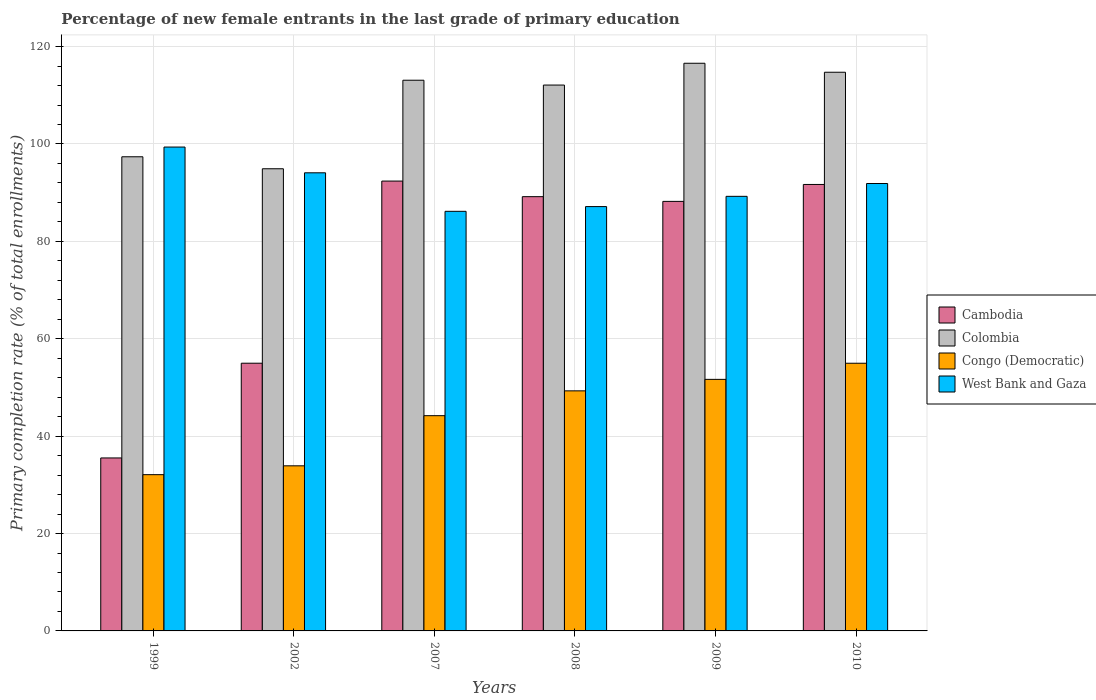How many different coloured bars are there?
Offer a terse response. 4. How many groups of bars are there?
Give a very brief answer. 6. Are the number of bars per tick equal to the number of legend labels?
Keep it short and to the point. Yes. Are the number of bars on each tick of the X-axis equal?
Offer a very short reply. Yes. How many bars are there on the 3rd tick from the right?
Ensure brevity in your answer.  4. What is the label of the 2nd group of bars from the left?
Offer a very short reply. 2002. What is the percentage of new female entrants in West Bank and Gaza in 2009?
Ensure brevity in your answer.  89.25. Across all years, what is the maximum percentage of new female entrants in Cambodia?
Give a very brief answer. 92.38. Across all years, what is the minimum percentage of new female entrants in Congo (Democratic)?
Your response must be concise. 32.09. In which year was the percentage of new female entrants in Congo (Democratic) minimum?
Your response must be concise. 1999. What is the total percentage of new female entrants in West Bank and Gaza in the graph?
Make the answer very short. 547.87. What is the difference between the percentage of new female entrants in Colombia in 1999 and that in 2010?
Offer a terse response. -17.36. What is the difference between the percentage of new female entrants in Cambodia in 2008 and the percentage of new female entrants in Colombia in 1999?
Your response must be concise. -8.19. What is the average percentage of new female entrants in West Bank and Gaza per year?
Ensure brevity in your answer.  91.31. In the year 2008, what is the difference between the percentage of new female entrants in Colombia and percentage of new female entrants in West Bank and Gaza?
Provide a short and direct response. 24.96. In how many years, is the percentage of new female entrants in West Bank and Gaza greater than 4 %?
Make the answer very short. 6. What is the ratio of the percentage of new female entrants in Cambodia in 1999 to that in 2010?
Offer a very short reply. 0.39. Is the percentage of new female entrants in Cambodia in 1999 less than that in 2010?
Give a very brief answer. Yes. Is the difference between the percentage of new female entrants in Colombia in 2002 and 2009 greater than the difference between the percentage of new female entrants in West Bank and Gaza in 2002 and 2009?
Your answer should be very brief. No. What is the difference between the highest and the second highest percentage of new female entrants in West Bank and Gaza?
Give a very brief answer. 5.29. What is the difference between the highest and the lowest percentage of new female entrants in Cambodia?
Your response must be concise. 56.86. In how many years, is the percentage of new female entrants in West Bank and Gaza greater than the average percentage of new female entrants in West Bank and Gaza taken over all years?
Give a very brief answer. 3. Is it the case that in every year, the sum of the percentage of new female entrants in West Bank and Gaza and percentage of new female entrants in Cambodia is greater than the sum of percentage of new female entrants in Colombia and percentage of new female entrants in Congo (Democratic)?
Give a very brief answer. No. What does the 4th bar from the left in 1999 represents?
Offer a terse response. West Bank and Gaza. What does the 4th bar from the right in 2002 represents?
Your response must be concise. Cambodia. Is it the case that in every year, the sum of the percentage of new female entrants in Cambodia and percentage of new female entrants in Congo (Democratic) is greater than the percentage of new female entrants in West Bank and Gaza?
Offer a very short reply. No. How many years are there in the graph?
Make the answer very short. 6. What is the difference between two consecutive major ticks on the Y-axis?
Ensure brevity in your answer.  20. Does the graph contain any zero values?
Your answer should be compact. No. Does the graph contain grids?
Provide a succinct answer. Yes. How many legend labels are there?
Offer a terse response. 4. How are the legend labels stacked?
Your answer should be compact. Vertical. What is the title of the graph?
Your answer should be compact. Percentage of new female entrants in the last grade of primary education. What is the label or title of the Y-axis?
Provide a short and direct response. Primary completion rate (% of total enrollments). What is the Primary completion rate (% of total enrollments) of Cambodia in 1999?
Your answer should be compact. 35.52. What is the Primary completion rate (% of total enrollments) in Colombia in 1999?
Your answer should be compact. 97.37. What is the Primary completion rate (% of total enrollments) in Congo (Democratic) in 1999?
Your answer should be compact. 32.09. What is the Primary completion rate (% of total enrollments) in West Bank and Gaza in 1999?
Offer a terse response. 99.36. What is the Primary completion rate (% of total enrollments) of Cambodia in 2002?
Offer a terse response. 54.98. What is the Primary completion rate (% of total enrollments) in Colombia in 2002?
Your response must be concise. 94.91. What is the Primary completion rate (% of total enrollments) in Congo (Democratic) in 2002?
Your response must be concise. 33.91. What is the Primary completion rate (% of total enrollments) of West Bank and Gaza in 2002?
Ensure brevity in your answer.  94.08. What is the Primary completion rate (% of total enrollments) of Cambodia in 2007?
Offer a terse response. 92.38. What is the Primary completion rate (% of total enrollments) in Colombia in 2007?
Make the answer very short. 113.09. What is the Primary completion rate (% of total enrollments) of Congo (Democratic) in 2007?
Keep it short and to the point. 44.2. What is the Primary completion rate (% of total enrollments) of West Bank and Gaza in 2007?
Offer a terse response. 86.17. What is the Primary completion rate (% of total enrollments) in Cambodia in 2008?
Offer a terse response. 89.18. What is the Primary completion rate (% of total enrollments) of Colombia in 2008?
Your answer should be compact. 112.1. What is the Primary completion rate (% of total enrollments) in Congo (Democratic) in 2008?
Make the answer very short. 49.3. What is the Primary completion rate (% of total enrollments) of West Bank and Gaza in 2008?
Keep it short and to the point. 87.14. What is the Primary completion rate (% of total enrollments) of Cambodia in 2009?
Provide a succinct answer. 88.21. What is the Primary completion rate (% of total enrollments) of Colombia in 2009?
Offer a terse response. 116.57. What is the Primary completion rate (% of total enrollments) of Congo (Democratic) in 2009?
Offer a terse response. 51.66. What is the Primary completion rate (% of total enrollments) in West Bank and Gaza in 2009?
Make the answer very short. 89.25. What is the Primary completion rate (% of total enrollments) of Cambodia in 2010?
Give a very brief answer. 91.68. What is the Primary completion rate (% of total enrollments) of Colombia in 2010?
Offer a terse response. 114.73. What is the Primary completion rate (% of total enrollments) in Congo (Democratic) in 2010?
Offer a very short reply. 54.97. What is the Primary completion rate (% of total enrollments) in West Bank and Gaza in 2010?
Offer a terse response. 91.88. Across all years, what is the maximum Primary completion rate (% of total enrollments) in Cambodia?
Provide a short and direct response. 92.38. Across all years, what is the maximum Primary completion rate (% of total enrollments) of Colombia?
Offer a terse response. 116.57. Across all years, what is the maximum Primary completion rate (% of total enrollments) of Congo (Democratic)?
Your response must be concise. 54.97. Across all years, what is the maximum Primary completion rate (% of total enrollments) in West Bank and Gaza?
Make the answer very short. 99.36. Across all years, what is the minimum Primary completion rate (% of total enrollments) in Cambodia?
Offer a terse response. 35.52. Across all years, what is the minimum Primary completion rate (% of total enrollments) in Colombia?
Give a very brief answer. 94.91. Across all years, what is the minimum Primary completion rate (% of total enrollments) of Congo (Democratic)?
Your answer should be compact. 32.09. Across all years, what is the minimum Primary completion rate (% of total enrollments) in West Bank and Gaza?
Provide a succinct answer. 86.17. What is the total Primary completion rate (% of total enrollments) in Cambodia in the graph?
Keep it short and to the point. 451.94. What is the total Primary completion rate (% of total enrollments) in Colombia in the graph?
Ensure brevity in your answer.  648.76. What is the total Primary completion rate (% of total enrollments) of Congo (Democratic) in the graph?
Make the answer very short. 266.12. What is the total Primary completion rate (% of total enrollments) in West Bank and Gaza in the graph?
Give a very brief answer. 547.87. What is the difference between the Primary completion rate (% of total enrollments) in Cambodia in 1999 and that in 2002?
Provide a succinct answer. -19.45. What is the difference between the Primary completion rate (% of total enrollments) of Colombia in 1999 and that in 2002?
Offer a very short reply. 2.46. What is the difference between the Primary completion rate (% of total enrollments) of Congo (Democratic) in 1999 and that in 2002?
Provide a succinct answer. -1.82. What is the difference between the Primary completion rate (% of total enrollments) of West Bank and Gaza in 1999 and that in 2002?
Ensure brevity in your answer.  5.29. What is the difference between the Primary completion rate (% of total enrollments) in Cambodia in 1999 and that in 2007?
Your answer should be compact. -56.86. What is the difference between the Primary completion rate (% of total enrollments) of Colombia in 1999 and that in 2007?
Your answer should be very brief. -15.72. What is the difference between the Primary completion rate (% of total enrollments) in Congo (Democratic) in 1999 and that in 2007?
Provide a short and direct response. -12.11. What is the difference between the Primary completion rate (% of total enrollments) of West Bank and Gaza in 1999 and that in 2007?
Keep it short and to the point. 13.2. What is the difference between the Primary completion rate (% of total enrollments) in Cambodia in 1999 and that in 2008?
Offer a very short reply. -53.66. What is the difference between the Primary completion rate (% of total enrollments) in Colombia in 1999 and that in 2008?
Provide a short and direct response. -14.73. What is the difference between the Primary completion rate (% of total enrollments) in Congo (Democratic) in 1999 and that in 2008?
Ensure brevity in your answer.  -17.21. What is the difference between the Primary completion rate (% of total enrollments) of West Bank and Gaza in 1999 and that in 2008?
Keep it short and to the point. 12.23. What is the difference between the Primary completion rate (% of total enrollments) in Cambodia in 1999 and that in 2009?
Provide a short and direct response. -52.69. What is the difference between the Primary completion rate (% of total enrollments) of Colombia in 1999 and that in 2009?
Provide a short and direct response. -19.2. What is the difference between the Primary completion rate (% of total enrollments) of Congo (Democratic) in 1999 and that in 2009?
Offer a very short reply. -19.57. What is the difference between the Primary completion rate (% of total enrollments) in West Bank and Gaza in 1999 and that in 2009?
Offer a very short reply. 10.12. What is the difference between the Primary completion rate (% of total enrollments) in Cambodia in 1999 and that in 2010?
Keep it short and to the point. -56.16. What is the difference between the Primary completion rate (% of total enrollments) of Colombia in 1999 and that in 2010?
Offer a very short reply. -17.36. What is the difference between the Primary completion rate (% of total enrollments) of Congo (Democratic) in 1999 and that in 2010?
Ensure brevity in your answer.  -22.88. What is the difference between the Primary completion rate (% of total enrollments) in West Bank and Gaza in 1999 and that in 2010?
Offer a very short reply. 7.49. What is the difference between the Primary completion rate (% of total enrollments) of Cambodia in 2002 and that in 2007?
Keep it short and to the point. -37.41. What is the difference between the Primary completion rate (% of total enrollments) of Colombia in 2002 and that in 2007?
Give a very brief answer. -18.18. What is the difference between the Primary completion rate (% of total enrollments) of Congo (Democratic) in 2002 and that in 2007?
Your answer should be very brief. -10.3. What is the difference between the Primary completion rate (% of total enrollments) in West Bank and Gaza in 2002 and that in 2007?
Ensure brevity in your answer.  7.91. What is the difference between the Primary completion rate (% of total enrollments) in Cambodia in 2002 and that in 2008?
Provide a succinct answer. -34.2. What is the difference between the Primary completion rate (% of total enrollments) of Colombia in 2002 and that in 2008?
Ensure brevity in your answer.  -17.19. What is the difference between the Primary completion rate (% of total enrollments) in Congo (Democratic) in 2002 and that in 2008?
Provide a short and direct response. -15.39. What is the difference between the Primary completion rate (% of total enrollments) in West Bank and Gaza in 2002 and that in 2008?
Provide a succinct answer. 6.94. What is the difference between the Primary completion rate (% of total enrollments) in Cambodia in 2002 and that in 2009?
Ensure brevity in your answer.  -33.23. What is the difference between the Primary completion rate (% of total enrollments) in Colombia in 2002 and that in 2009?
Ensure brevity in your answer.  -21.66. What is the difference between the Primary completion rate (% of total enrollments) of Congo (Democratic) in 2002 and that in 2009?
Ensure brevity in your answer.  -17.75. What is the difference between the Primary completion rate (% of total enrollments) of West Bank and Gaza in 2002 and that in 2009?
Your answer should be compact. 4.83. What is the difference between the Primary completion rate (% of total enrollments) of Cambodia in 2002 and that in 2010?
Your answer should be very brief. -36.71. What is the difference between the Primary completion rate (% of total enrollments) of Colombia in 2002 and that in 2010?
Provide a short and direct response. -19.82. What is the difference between the Primary completion rate (% of total enrollments) of Congo (Democratic) in 2002 and that in 2010?
Make the answer very short. -21.06. What is the difference between the Primary completion rate (% of total enrollments) of West Bank and Gaza in 2002 and that in 2010?
Keep it short and to the point. 2.2. What is the difference between the Primary completion rate (% of total enrollments) of Cambodia in 2007 and that in 2008?
Provide a short and direct response. 3.2. What is the difference between the Primary completion rate (% of total enrollments) in Colombia in 2007 and that in 2008?
Offer a very short reply. 0.99. What is the difference between the Primary completion rate (% of total enrollments) in Congo (Democratic) in 2007 and that in 2008?
Keep it short and to the point. -5.1. What is the difference between the Primary completion rate (% of total enrollments) of West Bank and Gaza in 2007 and that in 2008?
Your response must be concise. -0.97. What is the difference between the Primary completion rate (% of total enrollments) in Cambodia in 2007 and that in 2009?
Your answer should be very brief. 4.17. What is the difference between the Primary completion rate (% of total enrollments) in Colombia in 2007 and that in 2009?
Make the answer very short. -3.48. What is the difference between the Primary completion rate (% of total enrollments) of Congo (Democratic) in 2007 and that in 2009?
Your answer should be compact. -7.46. What is the difference between the Primary completion rate (% of total enrollments) in West Bank and Gaza in 2007 and that in 2009?
Your answer should be very brief. -3.08. What is the difference between the Primary completion rate (% of total enrollments) in Cambodia in 2007 and that in 2010?
Your answer should be very brief. 0.7. What is the difference between the Primary completion rate (% of total enrollments) of Colombia in 2007 and that in 2010?
Your answer should be compact. -1.64. What is the difference between the Primary completion rate (% of total enrollments) of Congo (Democratic) in 2007 and that in 2010?
Provide a succinct answer. -10.77. What is the difference between the Primary completion rate (% of total enrollments) of West Bank and Gaza in 2007 and that in 2010?
Your answer should be compact. -5.71. What is the difference between the Primary completion rate (% of total enrollments) in Cambodia in 2008 and that in 2009?
Make the answer very short. 0.97. What is the difference between the Primary completion rate (% of total enrollments) in Colombia in 2008 and that in 2009?
Keep it short and to the point. -4.47. What is the difference between the Primary completion rate (% of total enrollments) of Congo (Democratic) in 2008 and that in 2009?
Keep it short and to the point. -2.36. What is the difference between the Primary completion rate (% of total enrollments) of West Bank and Gaza in 2008 and that in 2009?
Ensure brevity in your answer.  -2.11. What is the difference between the Primary completion rate (% of total enrollments) in Cambodia in 2008 and that in 2010?
Provide a short and direct response. -2.5. What is the difference between the Primary completion rate (% of total enrollments) of Colombia in 2008 and that in 2010?
Keep it short and to the point. -2.63. What is the difference between the Primary completion rate (% of total enrollments) in Congo (Democratic) in 2008 and that in 2010?
Offer a very short reply. -5.67. What is the difference between the Primary completion rate (% of total enrollments) in West Bank and Gaza in 2008 and that in 2010?
Provide a short and direct response. -4.74. What is the difference between the Primary completion rate (% of total enrollments) of Cambodia in 2009 and that in 2010?
Your answer should be very brief. -3.47. What is the difference between the Primary completion rate (% of total enrollments) of Colombia in 2009 and that in 2010?
Your answer should be very brief. 1.85. What is the difference between the Primary completion rate (% of total enrollments) in Congo (Democratic) in 2009 and that in 2010?
Provide a succinct answer. -3.31. What is the difference between the Primary completion rate (% of total enrollments) of West Bank and Gaza in 2009 and that in 2010?
Offer a terse response. -2.63. What is the difference between the Primary completion rate (% of total enrollments) of Cambodia in 1999 and the Primary completion rate (% of total enrollments) of Colombia in 2002?
Offer a very short reply. -59.39. What is the difference between the Primary completion rate (% of total enrollments) in Cambodia in 1999 and the Primary completion rate (% of total enrollments) in Congo (Democratic) in 2002?
Give a very brief answer. 1.62. What is the difference between the Primary completion rate (% of total enrollments) of Cambodia in 1999 and the Primary completion rate (% of total enrollments) of West Bank and Gaza in 2002?
Make the answer very short. -58.56. What is the difference between the Primary completion rate (% of total enrollments) in Colombia in 1999 and the Primary completion rate (% of total enrollments) in Congo (Democratic) in 2002?
Your response must be concise. 63.46. What is the difference between the Primary completion rate (% of total enrollments) in Colombia in 1999 and the Primary completion rate (% of total enrollments) in West Bank and Gaza in 2002?
Provide a succinct answer. 3.29. What is the difference between the Primary completion rate (% of total enrollments) in Congo (Democratic) in 1999 and the Primary completion rate (% of total enrollments) in West Bank and Gaza in 2002?
Your answer should be compact. -61.99. What is the difference between the Primary completion rate (% of total enrollments) in Cambodia in 1999 and the Primary completion rate (% of total enrollments) in Colombia in 2007?
Your answer should be very brief. -77.57. What is the difference between the Primary completion rate (% of total enrollments) of Cambodia in 1999 and the Primary completion rate (% of total enrollments) of Congo (Democratic) in 2007?
Your answer should be compact. -8.68. What is the difference between the Primary completion rate (% of total enrollments) of Cambodia in 1999 and the Primary completion rate (% of total enrollments) of West Bank and Gaza in 2007?
Offer a very short reply. -50.65. What is the difference between the Primary completion rate (% of total enrollments) of Colombia in 1999 and the Primary completion rate (% of total enrollments) of Congo (Democratic) in 2007?
Offer a terse response. 53.17. What is the difference between the Primary completion rate (% of total enrollments) of Colombia in 1999 and the Primary completion rate (% of total enrollments) of West Bank and Gaza in 2007?
Give a very brief answer. 11.2. What is the difference between the Primary completion rate (% of total enrollments) of Congo (Democratic) in 1999 and the Primary completion rate (% of total enrollments) of West Bank and Gaza in 2007?
Give a very brief answer. -54.08. What is the difference between the Primary completion rate (% of total enrollments) in Cambodia in 1999 and the Primary completion rate (% of total enrollments) in Colombia in 2008?
Offer a very short reply. -76.58. What is the difference between the Primary completion rate (% of total enrollments) in Cambodia in 1999 and the Primary completion rate (% of total enrollments) in Congo (Democratic) in 2008?
Provide a succinct answer. -13.78. What is the difference between the Primary completion rate (% of total enrollments) in Cambodia in 1999 and the Primary completion rate (% of total enrollments) in West Bank and Gaza in 2008?
Offer a very short reply. -51.62. What is the difference between the Primary completion rate (% of total enrollments) in Colombia in 1999 and the Primary completion rate (% of total enrollments) in Congo (Democratic) in 2008?
Offer a terse response. 48.07. What is the difference between the Primary completion rate (% of total enrollments) of Colombia in 1999 and the Primary completion rate (% of total enrollments) of West Bank and Gaza in 2008?
Give a very brief answer. 10.23. What is the difference between the Primary completion rate (% of total enrollments) of Congo (Democratic) in 1999 and the Primary completion rate (% of total enrollments) of West Bank and Gaza in 2008?
Provide a short and direct response. -55.05. What is the difference between the Primary completion rate (% of total enrollments) in Cambodia in 1999 and the Primary completion rate (% of total enrollments) in Colombia in 2009?
Offer a very short reply. -81.05. What is the difference between the Primary completion rate (% of total enrollments) in Cambodia in 1999 and the Primary completion rate (% of total enrollments) in Congo (Democratic) in 2009?
Provide a succinct answer. -16.14. What is the difference between the Primary completion rate (% of total enrollments) in Cambodia in 1999 and the Primary completion rate (% of total enrollments) in West Bank and Gaza in 2009?
Give a very brief answer. -53.73. What is the difference between the Primary completion rate (% of total enrollments) of Colombia in 1999 and the Primary completion rate (% of total enrollments) of Congo (Democratic) in 2009?
Your response must be concise. 45.71. What is the difference between the Primary completion rate (% of total enrollments) of Colombia in 1999 and the Primary completion rate (% of total enrollments) of West Bank and Gaza in 2009?
Ensure brevity in your answer.  8.12. What is the difference between the Primary completion rate (% of total enrollments) of Congo (Democratic) in 1999 and the Primary completion rate (% of total enrollments) of West Bank and Gaza in 2009?
Keep it short and to the point. -57.16. What is the difference between the Primary completion rate (% of total enrollments) of Cambodia in 1999 and the Primary completion rate (% of total enrollments) of Colombia in 2010?
Offer a very short reply. -79.21. What is the difference between the Primary completion rate (% of total enrollments) in Cambodia in 1999 and the Primary completion rate (% of total enrollments) in Congo (Democratic) in 2010?
Make the answer very short. -19.45. What is the difference between the Primary completion rate (% of total enrollments) of Cambodia in 1999 and the Primary completion rate (% of total enrollments) of West Bank and Gaza in 2010?
Your answer should be very brief. -56.36. What is the difference between the Primary completion rate (% of total enrollments) in Colombia in 1999 and the Primary completion rate (% of total enrollments) in Congo (Democratic) in 2010?
Offer a terse response. 42.4. What is the difference between the Primary completion rate (% of total enrollments) of Colombia in 1999 and the Primary completion rate (% of total enrollments) of West Bank and Gaza in 2010?
Make the answer very short. 5.49. What is the difference between the Primary completion rate (% of total enrollments) in Congo (Democratic) in 1999 and the Primary completion rate (% of total enrollments) in West Bank and Gaza in 2010?
Offer a terse response. -59.79. What is the difference between the Primary completion rate (% of total enrollments) of Cambodia in 2002 and the Primary completion rate (% of total enrollments) of Colombia in 2007?
Your answer should be compact. -58.11. What is the difference between the Primary completion rate (% of total enrollments) in Cambodia in 2002 and the Primary completion rate (% of total enrollments) in Congo (Democratic) in 2007?
Your answer should be very brief. 10.77. What is the difference between the Primary completion rate (% of total enrollments) in Cambodia in 2002 and the Primary completion rate (% of total enrollments) in West Bank and Gaza in 2007?
Provide a short and direct response. -31.19. What is the difference between the Primary completion rate (% of total enrollments) in Colombia in 2002 and the Primary completion rate (% of total enrollments) in Congo (Democratic) in 2007?
Give a very brief answer. 50.71. What is the difference between the Primary completion rate (% of total enrollments) of Colombia in 2002 and the Primary completion rate (% of total enrollments) of West Bank and Gaza in 2007?
Provide a short and direct response. 8.74. What is the difference between the Primary completion rate (% of total enrollments) in Congo (Democratic) in 2002 and the Primary completion rate (% of total enrollments) in West Bank and Gaza in 2007?
Your answer should be very brief. -52.26. What is the difference between the Primary completion rate (% of total enrollments) of Cambodia in 2002 and the Primary completion rate (% of total enrollments) of Colombia in 2008?
Make the answer very short. -57.12. What is the difference between the Primary completion rate (% of total enrollments) in Cambodia in 2002 and the Primary completion rate (% of total enrollments) in Congo (Democratic) in 2008?
Give a very brief answer. 5.68. What is the difference between the Primary completion rate (% of total enrollments) of Cambodia in 2002 and the Primary completion rate (% of total enrollments) of West Bank and Gaza in 2008?
Provide a succinct answer. -32.16. What is the difference between the Primary completion rate (% of total enrollments) in Colombia in 2002 and the Primary completion rate (% of total enrollments) in Congo (Democratic) in 2008?
Provide a short and direct response. 45.61. What is the difference between the Primary completion rate (% of total enrollments) in Colombia in 2002 and the Primary completion rate (% of total enrollments) in West Bank and Gaza in 2008?
Give a very brief answer. 7.77. What is the difference between the Primary completion rate (% of total enrollments) in Congo (Democratic) in 2002 and the Primary completion rate (% of total enrollments) in West Bank and Gaza in 2008?
Your response must be concise. -53.23. What is the difference between the Primary completion rate (% of total enrollments) in Cambodia in 2002 and the Primary completion rate (% of total enrollments) in Colombia in 2009?
Your response must be concise. -61.6. What is the difference between the Primary completion rate (% of total enrollments) of Cambodia in 2002 and the Primary completion rate (% of total enrollments) of Congo (Democratic) in 2009?
Give a very brief answer. 3.32. What is the difference between the Primary completion rate (% of total enrollments) of Cambodia in 2002 and the Primary completion rate (% of total enrollments) of West Bank and Gaza in 2009?
Your answer should be very brief. -34.27. What is the difference between the Primary completion rate (% of total enrollments) of Colombia in 2002 and the Primary completion rate (% of total enrollments) of Congo (Democratic) in 2009?
Your response must be concise. 43.25. What is the difference between the Primary completion rate (% of total enrollments) in Colombia in 2002 and the Primary completion rate (% of total enrollments) in West Bank and Gaza in 2009?
Provide a succinct answer. 5.66. What is the difference between the Primary completion rate (% of total enrollments) of Congo (Democratic) in 2002 and the Primary completion rate (% of total enrollments) of West Bank and Gaza in 2009?
Your response must be concise. -55.34. What is the difference between the Primary completion rate (% of total enrollments) of Cambodia in 2002 and the Primary completion rate (% of total enrollments) of Colombia in 2010?
Ensure brevity in your answer.  -59.75. What is the difference between the Primary completion rate (% of total enrollments) in Cambodia in 2002 and the Primary completion rate (% of total enrollments) in Congo (Democratic) in 2010?
Offer a very short reply. 0.01. What is the difference between the Primary completion rate (% of total enrollments) in Cambodia in 2002 and the Primary completion rate (% of total enrollments) in West Bank and Gaza in 2010?
Provide a succinct answer. -36.9. What is the difference between the Primary completion rate (% of total enrollments) in Colombia in 2002 and the Primary completion rate (% of total enrollments) in Congo (Democratic) in 2010?
Ensure brevity in your answer.  39.94. What is the difference between the Primary completion rate (% of total enrollments) of Colombia in 2002 and the Primary completion rate (% of total enrollments) of West Bank and Gaza in 2010?
Offer a very short reply. 3.03. What is the difference between the Primary completion rate (% of total enrollments) of Congo (Democratic) in 2002 and the Primary completion rate (% of total enrollments) of West Bank and Gaza in 2010?
Make the answer very short. -57.97. What is the difference between the Primary completion rate (% of total enrollments) in Cambodia in 2007 and the Primary completion rate (% of total enrollments) in Colombia in 2008?
Offer a terse response. -19.72. What is the difference between the Primary completion rate (% of total enrollments) of Cambodia in 2007 and the Primary completion rate (% of total enrollments) of Congo (Democratic) in 2008?
Your answer should be compact. 43.08. What is the difference between the Primary completion rate (% of total enrollments) of Cambodia in 2007 and the Primary completion rate (% of total enrollments) of West Bank and Gaza in 2008?
Keep it short and to the point. 5.24. What is the difference between the Primary completion rate (% of total enrollments) of Colombia in 2007 and the Primary completion rate (% of total enrollments) of Congo (Democratic) in 2008?
Provide a short and direct response. 63.79. What is the difference between the Primary completion rate (% of total enrollments) in Colombia in 2007 and the Primary completion rate (% of total enrollments) in West Bank and Gaza in 2008?
Give a very brief answer. 25.95. What is the difference between the Primary completion rate (% of total enrollments) of Congo (Democratic) in 2007 and the Primary completion rate (% of total enrollments) of West Bank and Gaza in 2008?
Offer a very short reply. -42.94. What is the difference between the Primary completion rate (% of total enrollments) in Cambodia in 2007 and the Primary completion rate (% of total enrollments) in Colombia in 2009?
Offer a terse response. -24.19. What is the difference between the Primary completion rate (% of total enrollments) of Cambodia in 2007 and the Primary completion rate (% of total enrollments) of Congo (Democratic) in 2009?
Keep it short and to the point. 40.72. What is the difference between the Primary completion rate (% of total enrollments) of Cambodia in 2007 and the Primary completion rate (% of total enrollments) of West Bank and Gaza in 2009?
Ensure brevity in your answer.  3.13. What is the difference between the Primary completion rate (% of total enrollments) in Colombia in 2007 and the Primary completion rate (% of total enrollments) in Congo (Democratic) in 2009?
Give a very brief answer. 61.43. What is the difference between the Primary completion rate (% of total enrollments) of Colombia in 2007 and the Primary completion rate (% of total enrollments) of West Bank and Gaza in 2009?
Make the answer very short. 23.84. What is the difference between the Primary completion rate (% of total enrollments) in Congo (Democratic) in 2007 and the Primary completion rate (% of total enrollments) in West Bank and Gaza in 2009?
Your answer should be compact. -45.04. What is the difference between the Primary completion rate (% of total enrollments) in Cambodia in 2007 and the Primary completion rate (% of total enrollments) in Colombia in 2010?
Provide a succinct answer. -22.35. What is the difference between the Primary completion rate (% of total enrollments) in Cambodia in 2007 and the Primary completion rate (% of total enrollments) in Congo (Democratic) in 2010?
Your response must be concise. 37.41. What is the difference between the Primary completion rate (% of total enrollments) in Cambodia in 2007 and the Primary completion rate (% of total enrollments) in West Bank and Gaza in 2010?
Make the answer very short. 0.5. What is the difference between the Primary completion rate (% of total enrollments) in Colombia in 2007 and the Primary completion rate (% of total enrollments) in Congo (Democratic) in 2010?
Your answer should be very brief. 58.12. What is the difference between the Primary completion rate (% of total enrollments) in Colombia in 2007 and the Primary completion rate (% of total enrollments) in West Bank and Gaza in 2010?
Ensure brevity in your answer.  21.21. What is the difference between the Primary completion rate (% of total enrollments) of Congo (Democratic) in 2007 and the Primary completion rate (% of total enrollments) of West Bank and Gaza in 2010?
Give a very brief answer. -47.68. What is the difference between the Primary completion rate (% of total enrollments) of Cambodia in 2008 and the Primary completion rate (% of total enrollments) of Colombia in 2009?
Keep it short and to the point. -27.39. What is the difference between the Primary completion rate (% of total enrollments) of Cambodia in 2008 and the Primary completion rate (% of total enrollments) of Congo (Democratic) in 2009?
Offer a very short reply. 37.52. What is the difference between the Primary completion rate (% of total enrollments) in Cambodia in 2008 and the Primary completion rate (% of total enrollments) in West Bank and Gaza in 2009?
Provide a short and direct response. -0.07. What is the difference between the Primary completion rate (% of total enrollments) in Colombia in 2008 and the Primary completion rate (% of total enrollments) in Congo (Democratic) in 2009?
Offer a terse response. 60.44. What is the difference between the Primary completion rate (% of total enrollments) in Colombia in 2008 and the Primary completion rate (% of total enrollments) in West Bank and Gaza in 2009?
Ensure brevity in your answer.  22.85. What is the difference between the Primary completion rate (% of total enrollments) in Congo (Democratic) in 2008 and the Primary completion rate (% of total enrollments) in West Bank and Gaza in 2009?
Your response must be concise. -39.95. What is the difference between the Primary completion rate (% of total enrollments) of Cambodia in 2008 and the Primary completion rate (% of total enrollments) of Colombia in 2010?
Provide a succinct answer. -25.55. What is the difference between the Primary completion rate (% of total enrollments) of Cambodia in 2008 and the Primary completion rate (% of total enrollments) of Congo (Democratic) in 2010?
Your response must be concise. 34.21. What is the difference between the Primary completion rate (% of total enrollments) of Cambodia in 2008 and the Primary completion rate (% of total enrollments) of West Bank and Gaza in 2010?
Your response must be concise. -2.7. What is the difference between the Primary completion rate (% of total enrollments) in Colombia in 2008 and the Primary completion rate (% of total enrollments) in Congo (Democratic) in 2010?
Provide a short and direct response. 57.13. What is the difference between the Primary completion rate (% of total enrollments) of Colombia in 2008 and the Primary completion rate (% of total enrollments) of West Bank and Gaza in 2010?
Ensure brevity in your answer.  20.22. What is the difference between the Primary completion rate (% of total enrollments) in Congo (Democratic) in 2008 and the Primary completion rate (% of total enrollments) in West Bank and Gaza in 2010?
Give a very brief answer. -42.58. What is the difference between the Primary completion rate (% of total enrollments) in Cambodia in 2009 and the Primary completion rate (% of total enrollments) in Colombia in 2010?
Ensure brevity in your answer.  -26.52. What is the difference between the Primary completion rate (% of total enrollments) in Cambodia in 2009 and the Primary completion rate (% of total enrollments) in Congo (Democratic) in 2010?
Keep it short and to the point. 33.24. What is the difference between the Primary completion rate (% of total enrollments) in Cambodia in 2009 and the Primary completion rate (% of total enrollments) in West Bank and Gaza in 2010?
Your answer should be very brief. -3.67. What is the difference between the Primary completion rate (% of total enrollments) of Colombia in 2009 and the Primary completion rate (% of total enrollments) of Congo (Democratic) in 2010?
Your answer should be very brief. 61.6. What is the difference between the Primary completion rate (% of total enrollments) in Colombia in 2009 and the Primary completion rate (% of total enrollments) in West Bank and Gaza in 2010?
Make the answer very short. 24.69. What is the difference between the Primary completion rate (% of total enrollments) in Congo (Democratic) in 2009 and the Primary completion rate (% of total enrollments) in West Bank and Gaza in 2010?
Make the answer very short. -40.22. What is the average Primary completion rate (% of total enrollments) of Cambodia per year?
Keep it short and to the point. 75.32. What is the average Primary completion rate (% of total enrollments) in Colombia per year?
Your answer should be compact. 108.13. What is the average Primary completion rate (% of total enrollments) of Congo (Democratic) per year?
Your response must be concise. 44.35. What is the average Primary completion rate (% of total enrollments) in West Bank and Gaza per year?
Make the answer very short. 91.31. In the year 1999, what is the difference between the Primary completion rate (% of total enrollments) in Cambodia and Primary completion rate (% of total enrollments) in Colombia?
Offer a terse response. -61.85. In the year 1999, what is the difference between the Primary completion rate (% of total enrollments) in Cambodia and Primary completion rate (% of total enrollments) in Congo (Democratic)?
Your response must be concise. 3.43. In the year 1999, what is the difference between the Primary completion rate (% of total enrollments) in Cambodia and Primary completion rate (% of total enrollments) in West Bank and Gaza?
Your answer should be compact. -63.84. In the year 1999, what is the difference between the Primary completion rate (% of total enrollments) in Colombia and Primary completion rate (% of total enrollments) in Congo (Democratic)?
Ensure brevity in your answer.  65.28. In the year 1999, what is the difference between the Primary completion rate (% of total enrollments) of Colombia and Primary completion rate (% of total enrollments) of West Bank and Gaza?
Provide a short and direct response. -2. In the year 1999, what is the difference between the Primary completion rate (% of total enrollments) in Congo (Democratic) and Primary completion rate (% of total enrollments) in West Bank and Gaza?
Keep it short and to the point. -67.28. In the year 2002, what is the difference between the Primary completion rate (% of total enrollments) of Cambodia and Primary completion rate (% of total enrollments) of Colombia?
Keep it short and to the point. -39.93. In the year 2002, what is the difference between the Primary completion rate (% of total enrollments) in Cambodia and Primary completion rate (% of total enrollments) in Congo (Democratic)?
Ensure brevity in your answer.  21.07. In the year 2002, what is the difference between the Primary completion rate (% of total enrollments) in Cambodia and Primary completion rate (% of total enrollments) in West Bank and Gaza?
Provide a short and direct response. -39.1. In the year 2002, what is the difference between the Primary completion rate (% of total enrollments) of Colombia and Primary completion rate (% of total enrollments) of Congo (Democratic)?
Your answer should be compact. 61. In the year 2002, what is the difference between the Primary completion rate (% of total enrollments) in Colombia and Primary completion rate (% of total enrollments) in West Bank and Gaza?
Make the answer very short. 0.83. In the year 2002, what is the difference between the Primary completion rate (% of total enrollments) of Congo (Democratic) and Primary completion rate (% of total enrollments) of West Bank and Gaza?
Keep it short and to the point. -60.17. In the year 2007, what is the difference between the Primary completion rate (% of total enrollments) in Cambodia and Primary completion rate (% of total enrollments) in Colombia?
Ensure brevity in your answer.  -20.71. In the year 2007, what is the difference between the Primary completion rate (% of total enrollments) of Cambodia and Primary completion rate (% of total enrollments) of Congo (Democratic)?
Make the answer very short. 48.18. In the year 2007, what is the difference between the Primary completion rate (% of total enrollments) in Cambodia and Primary completion rate (% of total enrollments) in West Bank and Gaza?
Your answer should be very brief. 6.21. In the year 2007, what is the difference between the Primary completion rate (% of total enrollments) of Colombia and Primary completion rate (% of total enrollments) of Congo (Democratic)?
Provide a short and direct response. 68.89. In the year 2007, what is the difference between the Primary completion rate (% of total enrollments) of Colombia and Primary completion rate (% of total enrollments) of West Bank and Gaza?
Make the answer very short. 26.92. In the year 2007, what is the difference between the Primary completion rate (% of total enrollments) of Congo (Democratic) and Primary completion rate (% of total enrollments) of West Bank and Gaza?
Provide a succinct answer. -41.97. In the year 2008, what is the difference between the Primary completion rate (% of total enrollments) in Cambodia and Primary completion rate (% of total enrollments) in Colombia?
Offer a terse response. -22.92. In the year 2008, what is the difference between the Primary completion rate (% of total enrollments) of Cambodia and Primary completion rate (% of total enrollments) of Congo (Democratic)?
Provide a short and direct response. 39.88. In the year 2008, what is the difference between the Primary completion rate (% of total enrollments) in Cambodia and Primary completion rate (% of total enrollments) in West Bank and Gaza?
Make the answer very short. 2.04. In the year 2008, what is the difference between the Primary completion rate (% of total enrollments) in Colombia and Primary completion rate (% of total enrollments) in Congo (Democratic)?
Offer a terse response. 62.8. In the year 2008, what is the difference between the Primary completion rate (% of total enrollments) of Colombia and Primary completion rate (% of total enrollments) of West Bank and Gaza?
Offer a very short reply. 24.96. In the year 2008, what is the difference between the Primary completion rate (% of total enrollments) of Congo (Democratic) and Primary completion rate (% of total enrollments) of West Bank and Gaza?
Your response must be concise. -37.84. In the year 2009, what is the difference between the Primary completion rate (% of total enrollments) in Cambodia and Primary completion rate (% of total enrollments) in Colombia?
Make the answer very short. -28.37. In the year 2009, what is the difference between the Primary completion rate (% of total enrollments) of Cambodia and Primary completion rate (% of total enrollments) of Congo (Democratic)?
Keep it short and to the point. 36.55. In the year 2009, what is the difference between the Primary completion rate (% of total enrollments) in Cambodia and Primary completion rate (% of total enrollments) in West Bank and Gaza?
Give a very brief answer. -1.04. In the year 2009, what is the difference between the Primary completion rate (% of total enrollments) in Colombia and Primary completion rate (% of total enrollments) in Congo (Democratic)?
Give a very brief answer. 64.91. In the year 2009, what is the difference between the Primary completion rate (% of total enrollments) of Colombia and Primary completion rate (% of total enrollments) of West Bank and Gaza?
Ensure brevity in your answer.  27.33. In the year 2009, what is the difference between the Primary completion rate (% of total enrollments) in Congo (Democratic) and Primary completion rate (% of total enrollments) in West Bank and Gaza?
Make the answer very short. -37.59. In the year 2010, what is the difference between the Primary completion rate (% of total enrollments) in Cambodia and Primary completion rate (% of total enrollments) in Colombia?
Provide a succinct answer. -23.05. In the year 2010, what is the difference between the Primary completion rate (% of total enrollments) of Cambodia and Primary completion rate (% of total enrollments) of Congo (Democratic)?
Offer a very short reply. 36.71. In the year 2010, what is the difference between the Primary completion rate (% of total enrollments) in Cambodia and Primary completion rate (% of total enrollments) in West Bank and Gaza?
Your answer should be very brief. -0.2. In the year 2010, what is the difference between the Primary completion rate (% of total enrollments) in Colombia and Primary completion rate (% of total enrollments) in Congo (Democratic)?
Give a very brief answer. 59.76. In the year 2010, what is the difference between the Primary completion rate (% of total enrollments) in Colombia and Primary completion rate (% of total enrollments) in West Bank and Gaza?
Ensure brevity in your answer.  22.85. In the year 2010, what is the difference between the Primary completion rate (% of total enrollments) of Congo (Democratic) and Primary completion rate (% of total enrollments) of West Bank and Gaza?
Your response must be concise. -36.91. What is the ratio of the Primary completion rate (% of total enrollments) of Cambodia in 1999 to that in 2002?
Keep it short and to the point. 0.65. What is the ratio of the Primary completion rate (% of total enrollments) of Colombia in 1999 to that in 2002?
Offer a very short reply. 1.03. What is the ratio of the Primary completion rate (% of total enrollments) of Congo (Democratic) in 1999 to that in 2002?
Give a very brief answer. 0.95. What is the ratio of the Primary completion rate (% of total enrollments) of West Bank and Gaza in 1999 to that in 2002?
Offer a very short reply. 1.06. What is the ratio of the Primary completion rate (% of total enrollments) in Cambodia in 1999 to that in 2007?
Ensure brevity in your answer.  0.38. What is the ratio of the Primary completion rate (% of total enrollments) of Colombia in 1999 to that in 2007?
Offer a terse response. 0.86. What is the ratio of the Primary completion rate (% of total enrollments) of Congo (Democratic) in 1999 to that in 2007?
Offer a very short reply. 0.73. What is the ratio of the Primary completion rate (% of total enrollments) in West Bank and Gaza in 1999 to that in 2007?
Offer a very short reply. 1.15. What is the ratio of the Primary completion rate (% of total enrollments) of Cambodia in 1999 to that in 2008?
Keep it short and to the point. 0.4. What is the ratio of the Primary completion rate (% of total enrollments) in Colombia in 1999 to that in 2008?
Offer a terse response. 0.87. What is the ratio of the Primary completion rate (% of total enrollments) in Congo (Democratic) in 1999 to that in 2008?
Provide a succinct answer. 0.65. What is the ratio of the Primary completion rate (% of total enrollments) in West Bank and Gaza in 1999 to that in 2008?
Keep it short and to the point. 1.14. What is the ratio of the Primary completion rate (% of total enrollments) in Cambodia in 1999 to that in 2009?
Make the answer very short. 0.4. What is the ratio of the Primary completion rate (% of total enrollments) of Colombia in 1999 to that in 2009?
Your answer should be very brief. 0.84. What is the ratio of the Primary completion rate (% of total enrollments) in Congo (Democratic) in 1999 to that in 2009?
Provide a short and direct response. 0.62. What is the ratio of the Primary completion rate (% of total enrollments) of West Bank and Gaza in 1999 to that in 2009?
Make the answer very short. 1.11. What is the ratio of the Primary completion rate (% of total enrollments) of Cambodia in 1999 to that in 2010?
Offer a terse response. 0.39. What is the ratio of the Primary completion rate (% of total enrollments) in Colombia in 1999 to that in 2010?
Make the answer very short. 0.85. What is the ratio of the Primary completion rate (% of total enrollments) of Congo (Democratic) in 1999 to that in 2010?
Offer a very short reply. 0.58. What is the ratio of the Primary completion rate (% of total enrollments) of West Bank and Gaza in 1999 to that in 2010?
Offer a very short reply. 1.08. What is the ratio of the Primary completion rate (% of total enrollments) in Cambodia in 2002 to that in 2007?
Provide a succinct answer. 0.6. What is the ratio of the Primary completion rate (% of total enrollments) of Colombia in 2002 to that in 2007?
Give a very brief answer. 0.84. What is the ratio of the Primary completion rate (% of total enrollments) of Congo (Democratic) in 2002 to that in 2007?
Your answer should be very brief. 0.77. What is the ratio of the Primary completion rate (% of total enrollments) of West Bank and Gaza in 2002 to that in 2007?
Provide a succinct answer. 1.09. What is the ratio of the Primary completion rate (% of total enrollments) in Cambodia in 2002 to that in 2008?
Ensure brevity in your answer.  0.62. What is the ratio of the Primary completion rate (% of total enrollments) of Colombia in 2002 to that in 2008?
Provide a short and direct response. 0.85. What is the ratio of the Primary completion rate (% of total enrollments) of Congo (Democratic) in 2002 to that in 2008?
Make the answer very short. 0.69. What is the ratio of the Primary completion rate (% of total enrollments) in West Bank and Gaza in 2002 to that in 2008?
Keep it short and to the point. 1.08. What is the ratio of the Primary completion rate (% of total enrollments) in Cambodia in 2002 to that in 2009?
Your answer should be compact. 0.62. What is the ratio of the Primary completion rate (% of total enrollments) of Colombia in 2002 to that in 2009?
Offer a terse response. 0.81. What is the ratio of the Primary completion rate (% of total enrollments) of Congo (Democratic) in 2002 to that in 2009?
Offer a terse response. 0.66. What is the ratio of the Primary completion rate (% of total enrollments) of West Bank and Gaza in 2002 to that in 2009?
Make the answer very short. 1.05. What is the ratio of the Primary completion rate (% of total enrollments) of Cambodia in 2002 to that in 2010?
Offer a terse response. 0.6. What is the ratio of the Primary completion rate (% of total enrollments) in Colombia in 2002 to that in 2010?
Make the answer very short. 0.83. What is the ratio of the Primary completion rate (% of total enrollments) of Congo (Democratic) in 2002 to that in 2010?
Make the answer very short. 0.62. What is the ratio of the Primary completion rate (% of total enrollments) in West Bank and Gaza in 2002 to that in 2010?
Provide a succinct answer. 1.02. What is the ratio of the Primary completion rate (% of total enrollments) of Cambodia in 2007 to that in 2008?
Your answer should be compact. 1.04. What is the ratio of the Primary completion rate (% of total enrollments) of Colombia in 2007 to that in 2008?
Provide a succinct answer. 1.01. What is the ratio of the Primary completion rate (% of total enrollments) of Congo (Democratic) in 2007 to that in 2008?
Your answer should be very brief. 0.9. What is the ratio of the Primary completion rate (% of total enrollments) of West Bank and Gaza in 2007 to that in 2008?
Your answer should be very brief. 0.99. What is the ratio of the Primary completion rate (% of total enrollments) of Cambodia in 2007 to that in 2009?
Give a very brief answer. 1.05. What is the ratio of the Primary completion rate (% of total enrollments) of Colombia in 2007 to that in 2009?
Your answer should be very brief. 0.97. What is the ratio of the Primary completion rate (% of total enrollments) in Congo (Democratic) in 2007 to that in 2009?
Your response must be concise. 0.86. What is the ratio of the Primary completion rate (% of total enrollments) in West Bank and Gaza in 2007 to that in 2009?
Make the answer very short. 0.97. What is the ratio of the Primary completion rate (% of total enrollments) of Cambodia in 2007 to that in 2010?
Your answer should be compact. 1.01. What is the ratio of the Primary completion rate (% of total enrollments) in Colombia in 2007 to that in 2010?
Give a very brief answer. 0.99. What is the ratio of the Primary completion rate (% of total enrollments) in Congo (Democratic) in 2007 to that in 2010?
Ensure brevity in your answer.  0.8. What is the ratio of the Primary completion rate (% of total enrollments) of West Bank and Gaza in 2007 to that in 2010?
Provide a succinct answer. 0.94. What is the ratio of the Primary completion rate (% of total enrollments) in Colombia in 2008 to that in 2009?
Your answer should be very brief. 0.96. What is the ratio of the Primary completion rate (% of total enrollments) of Congo (Democratic) in 2008 to that in 2009?
Give a very brief answer. 0.95. What is the ratio of the Primary completion rate (% of total enrollments) in West Bank and Gaza in 2008 to that in 2009?
Your answer should be compact. 0.98. What is the ratio of the Primary completion rate (% of total enrollments) in Cambodia in 2008 to that in 2010?
Make the answer very short. 0.97. What is the ratio of the Primary completion rate (% of total enrollments) in Colombia in 2008 to that in 2010?
Ensure brevity in your answer.  0.98. What is the ratio of the Primary completion rate (% of total enrollments) of Congo (Democratic) in 2008 to that in 2010?
Ensure brevity in your answer.  0.9. What is the ratio of the Primary completion rate (% of total enrollments) of West Bank and Gaza in 2008 to that in 2010?
Give a very brief answer. 0.95. What is the ratio of the Primary completion rate (% of total enrollments) in Cambodia in 2009 to that in 2010?
Your response must be concise. 0.96. What is the ratio of the Primary completion rate (% of total enrollments) of Colombia in 2009 to that in 2010?
Keep it short and to the point. 1.02. What is the ratio of the Primary completion rate (% of total enrollments) in Congo (Democratic) in 2009 to that in 2010?
Your response must be concise. 0.94. What is the ratio of the Primary completion rate (% of total enrollments) of West Bank and Gaza in 2009 to that in 2010?
Your answer should be compact. 0.97. What is the difference between the highest and the second highest Primary completion rate (% of total enrollments) in Cambodia?
Keep it short and to the point. 0.7. What is the difference between the highest and the second highest Primary completion rate (% of total enrollments) in Colombia?
Provide a succinct answer. 1.85. What is the difference between the highest and the second highest Primary completion rate (% of total enrollments) in Congo (Democratic)?
Ensure brevity in your answer.  3.31. What is the difference between the highest and the second highest Primary completion rate (% of total enrollments) of West Bank and Gaza?
Your response must be concise. 5.29. What is the difference between the highest and the lowest Primary completion rate (% of total enrollments) in Cambodia?
Ensure brevity in your answer.  56.86. What is the difference between the highest and the lowest Primary completion rate (% of total enrollments) of Colombia?
Your answer should be very brief. 21.66. What is the difference between the highest and the lowest Primary completion rate (% of total enrollments) in Congo (Democratic)?
Make the answer very short. 22.88. What is the difference between the highest and the lowest Primary completion rate (% of total enrollments) in West Bank and Gaza?
Offer a terse response. 13.2. 